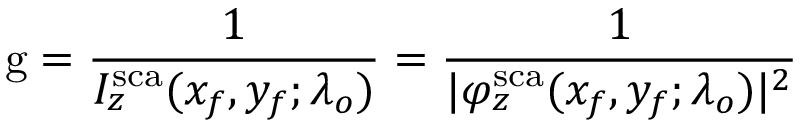Convert formula to latex. <formula><loc_0><loc_0><loc_500><loc_500>g = \frac { 1 } { I _ { z } ^ { s c a } ( x _ { f } , y _ { f } ; \lambda _ { o } ) } = \frac { 1 } { | \varphi _ { z } ^ { s c a } ( x _ { f } , y _ { f } ; \lambda _ { o } ) | ^ { 2 } }</formula> 